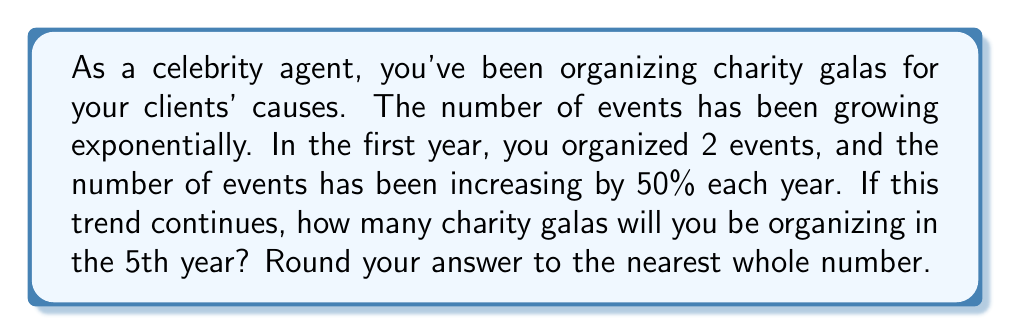Help me with this question. To solve this problem, we'll use the exponential growth model:

$$ A = P(1 + r)^t $$

Where:
$A$ = Final amount
$P$ = Initial amount
$r$ = Growth rate (as a decimal)
$t$ = Time period

Given:
$P = 2$ (initial number of events)
$r = 0.50$ (50% growth rate)
$t = 4$ (we want to know the 5th year, which is 4 years after the initial year)

Let's plug these values into our formula:

$$ A = 2(1 + 0.50)^4 $$

$$ A = 2(1.50)^4 $$

Now, let's calculate step by step:

1) First, calculate $(1.50)^4$:
   $1.50^2 = 2.25$
   $2.25^2 = 5.0625$

2) Multiply the result by 2:
   $2 * 5.0625 = 10.125$

3) Round to the nearest whole number:
   $10.125 ≈ 10$

Therefore, in the 5th year, you'll be organizing approximately 10 charity galas.
Answer: 10 charity galas 